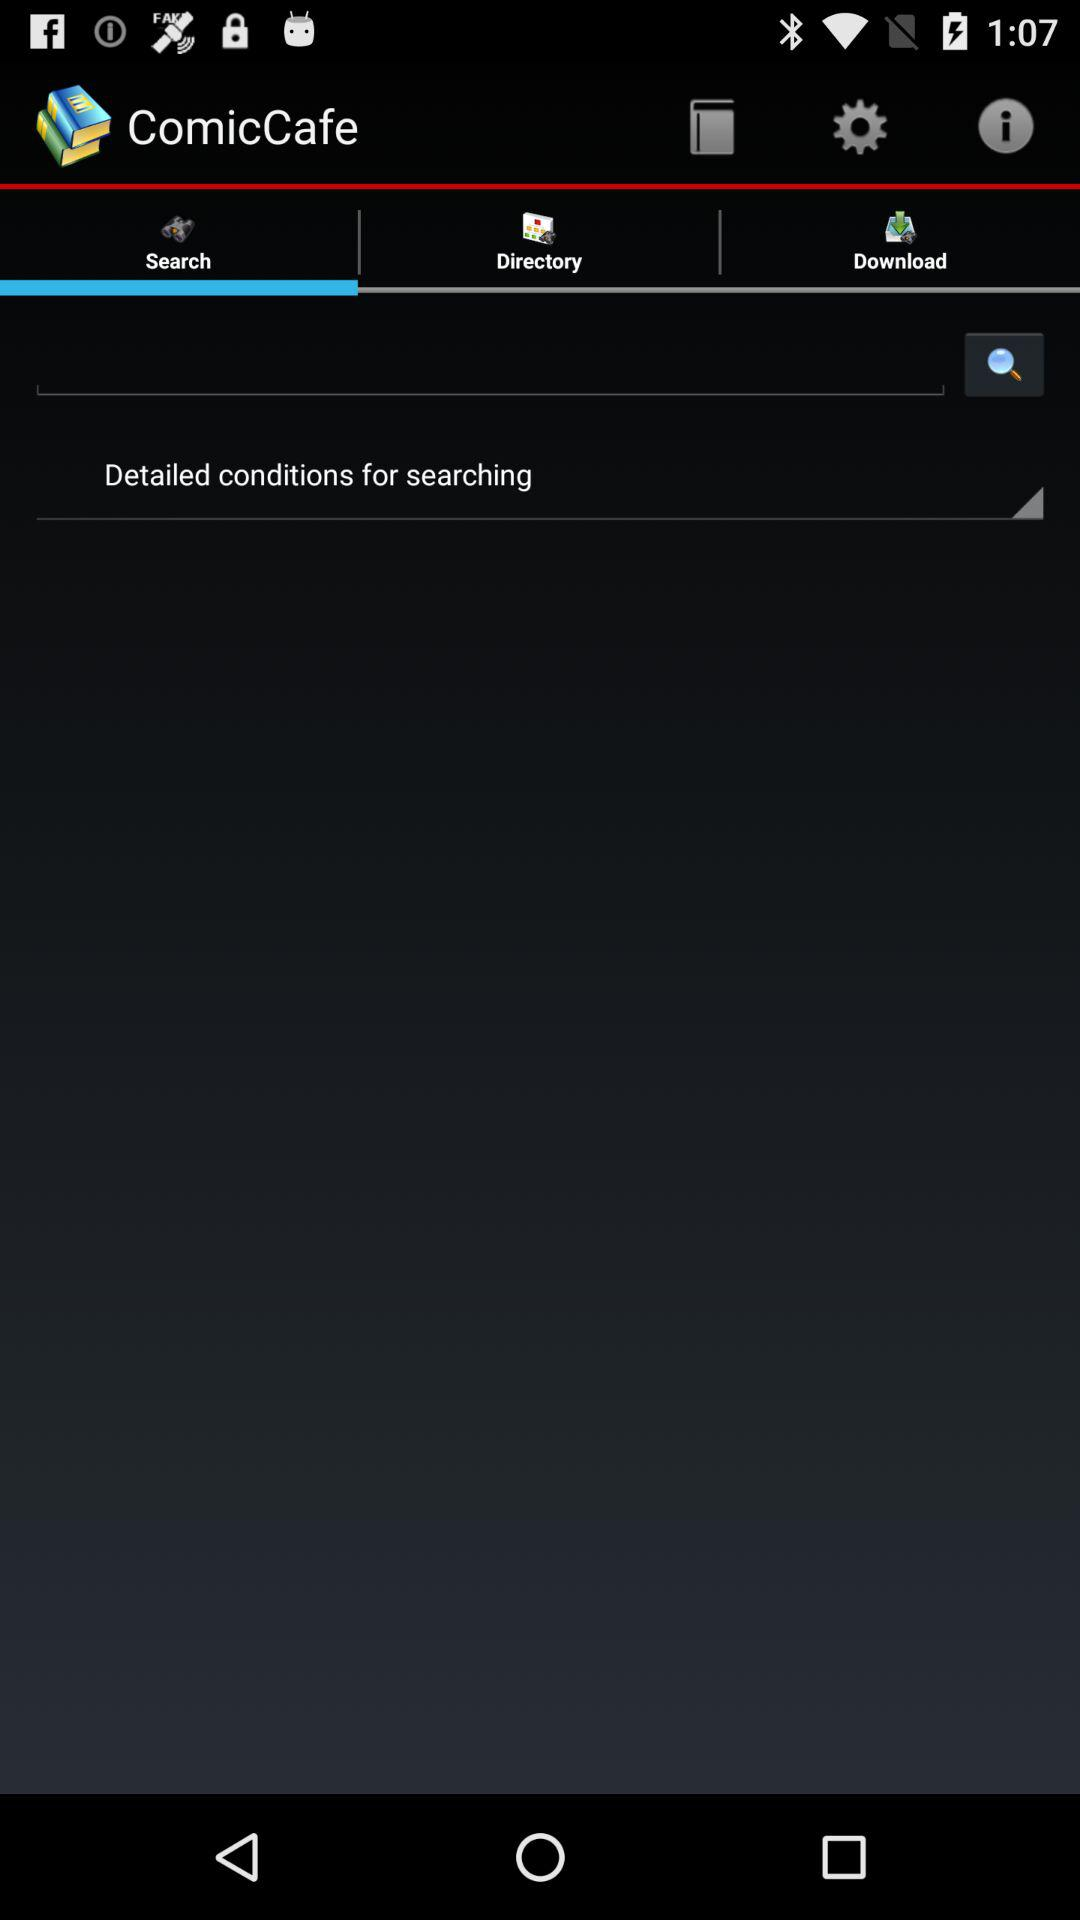Which tab is selected? The selected tab is "Search". 